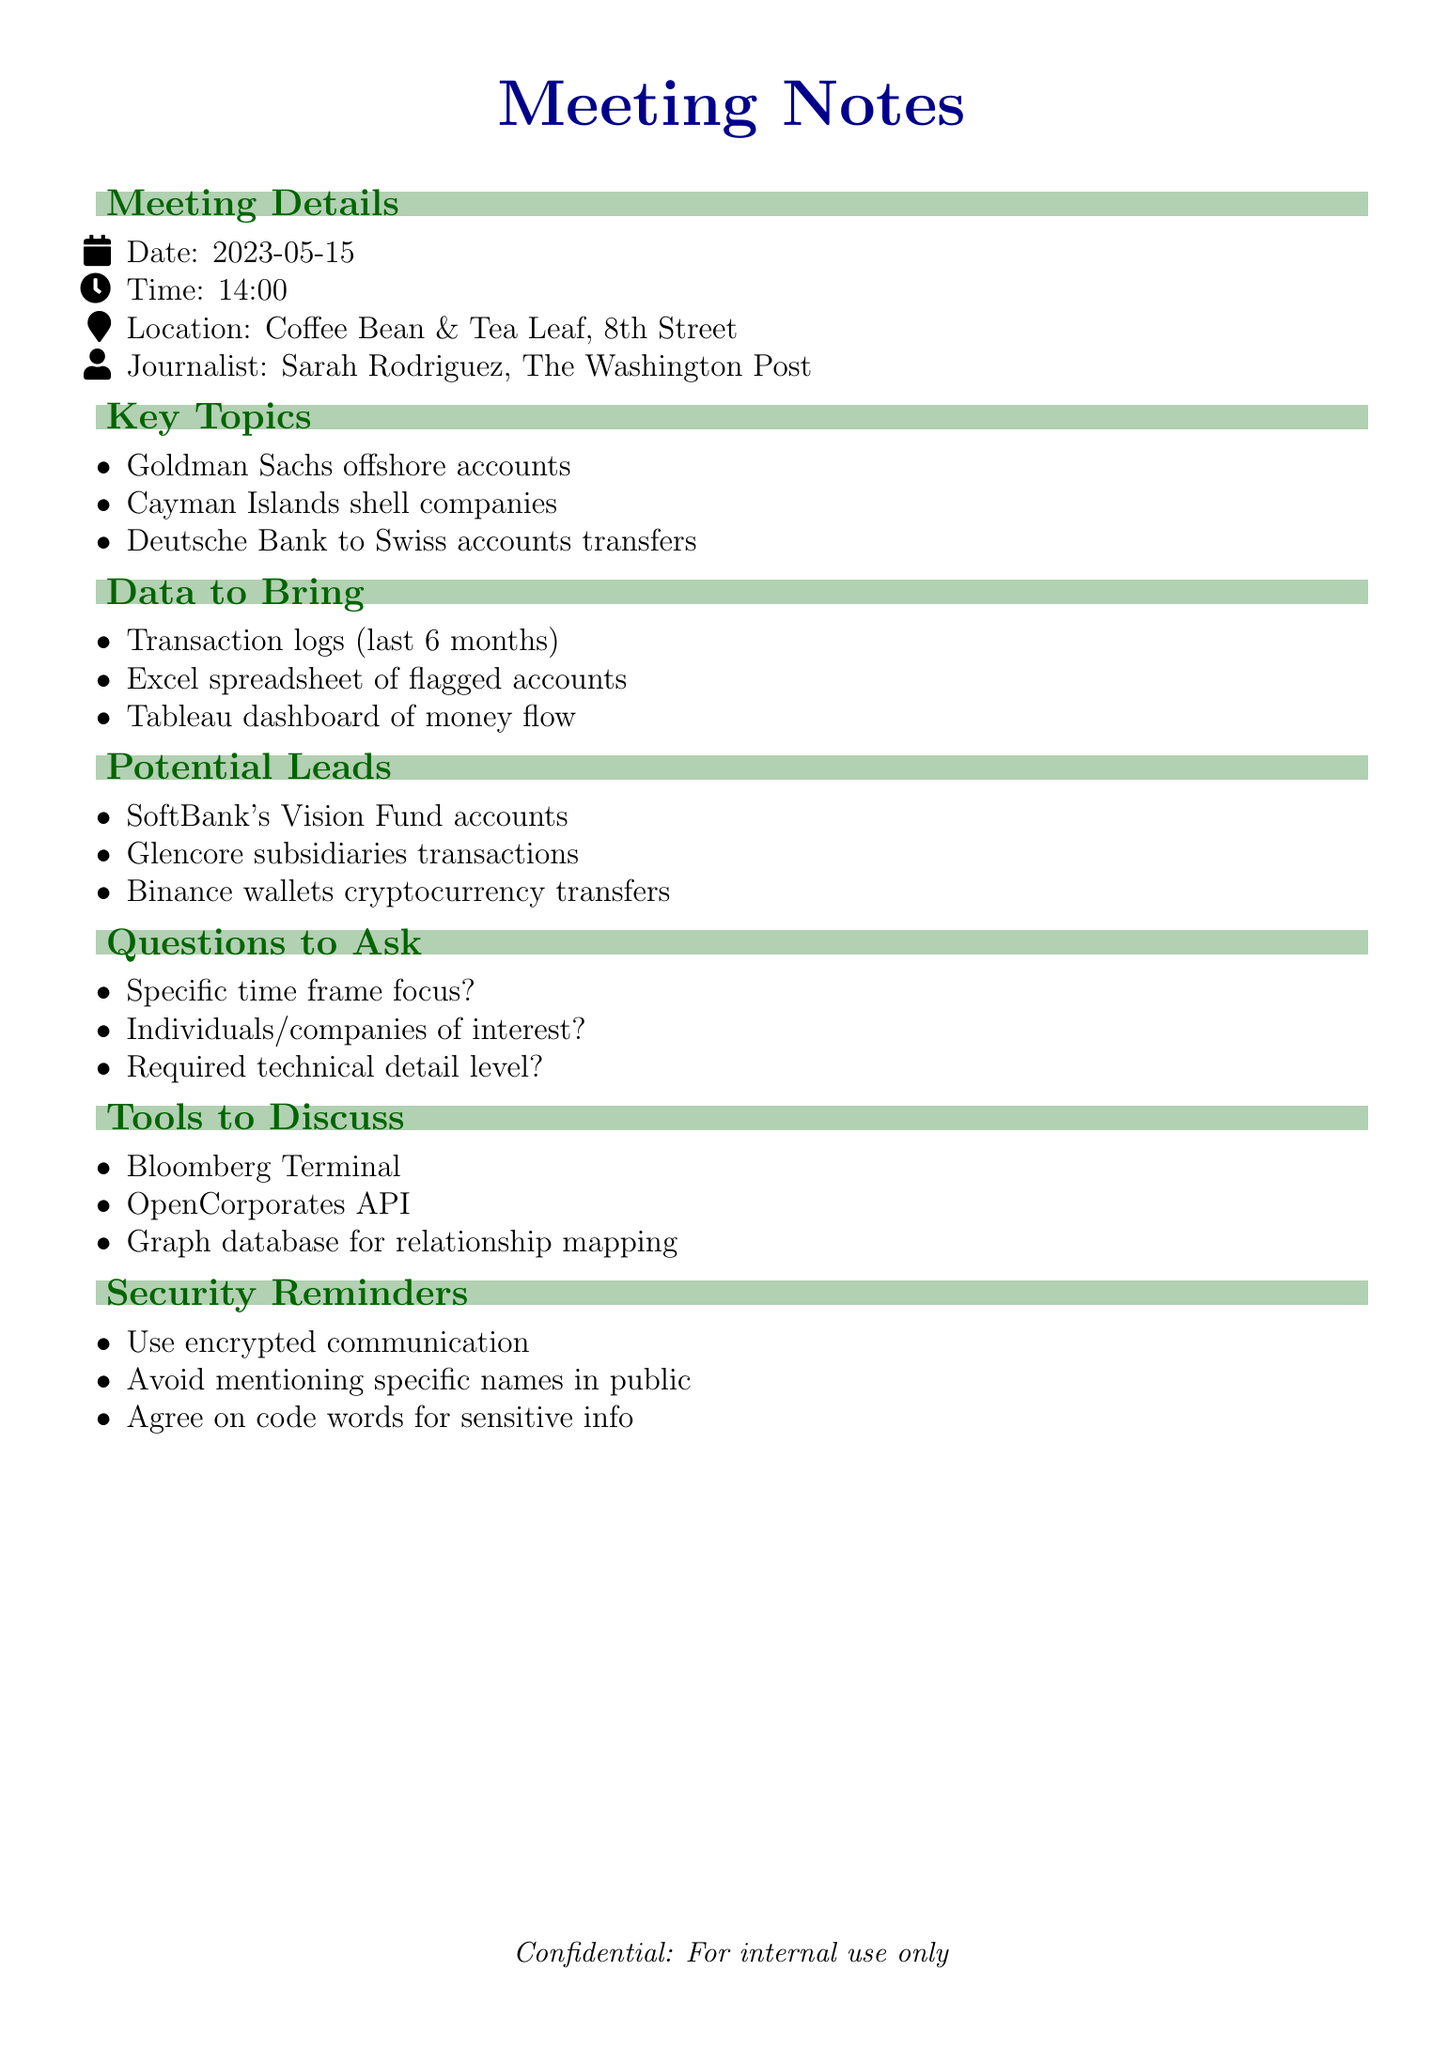what is the date of the meeting? The date of the meeting is found under the Meeting Details section.
Answer: 2023-05-15 who is the journalist attending the meeting? The journalist's name is listed in the Meeting Details section.
Answer: Sarah Rodriguez what are the key topics to be discussed? Key topics are presented in a list format; the first item is mentioned.
Answer: Goldman Sachs offshore accounts how many data sources should be brought to the meeting? The number of items in the Data to Bring section indicates this.
Answer: Three what is one potential lead mentioned? Potential leads are outlined, and one example is the first item listed.
Answer: Unusual activity in accounts related to SoftBank's Vision Fund what is the time of the meeting? The time of the meeting is specified under Meeting Details.
Answer: 14:00 what level of technical detail is required for the article? This question is among those designed to gather more specific project information.
Answer: Not specified what is one tool to discuss in the meeting? The Tools to Discuss section lists several tools, and one is provided as an example.
Answer: Bloomberg Terminal what location is the meeting held at? The location of the meeting is found in the Meeting Details section.
Answer: Coffee Bean & Tea Leaf, 8th Street 